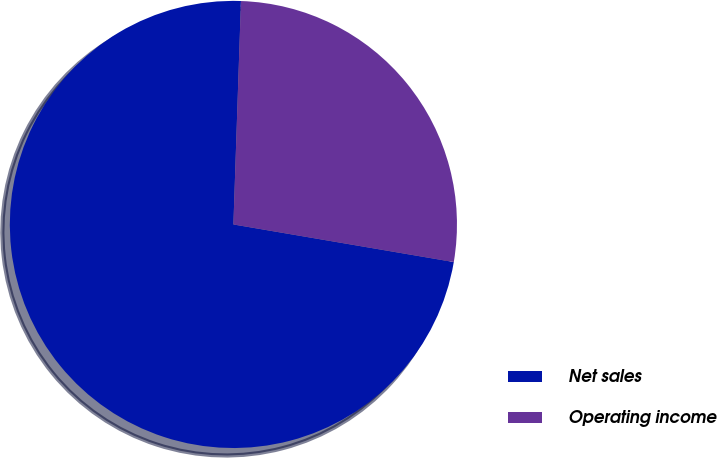Convert chart. <chart><loc_0><loc_0><loc_500><loc_500><pie_chart><fcel>Net sales<fcel>Operating income<nl><fcel>72.85%<fcel>27.15%<nl></chart> 